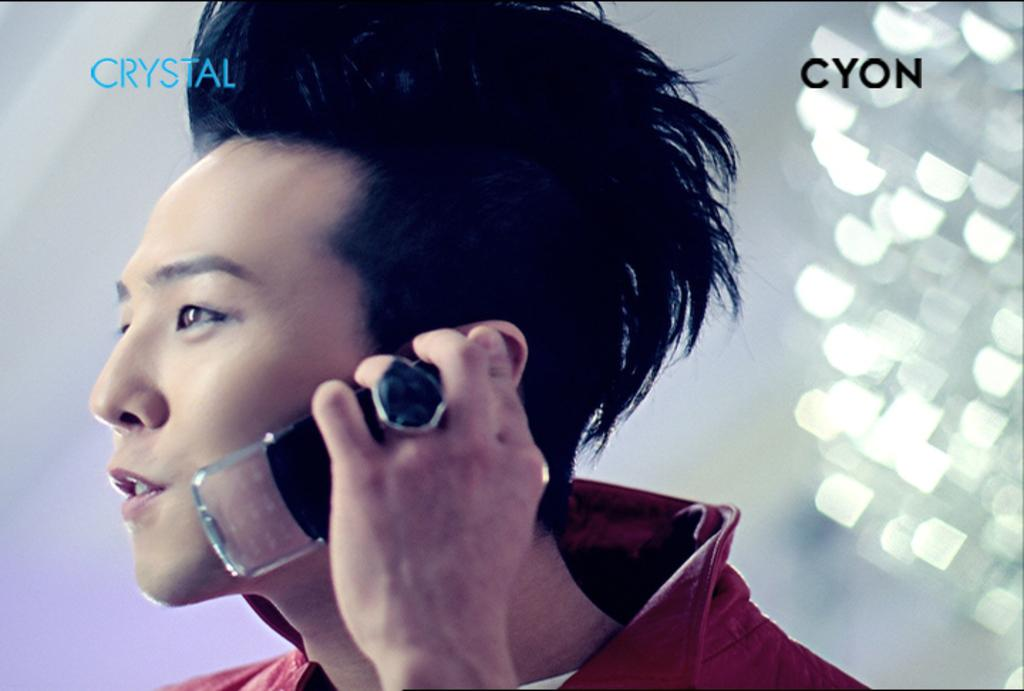<image>
Relay a brief, clear account of the picture shown. An advertisement of an Asian man holding a Crystal Cyon cellphone. 